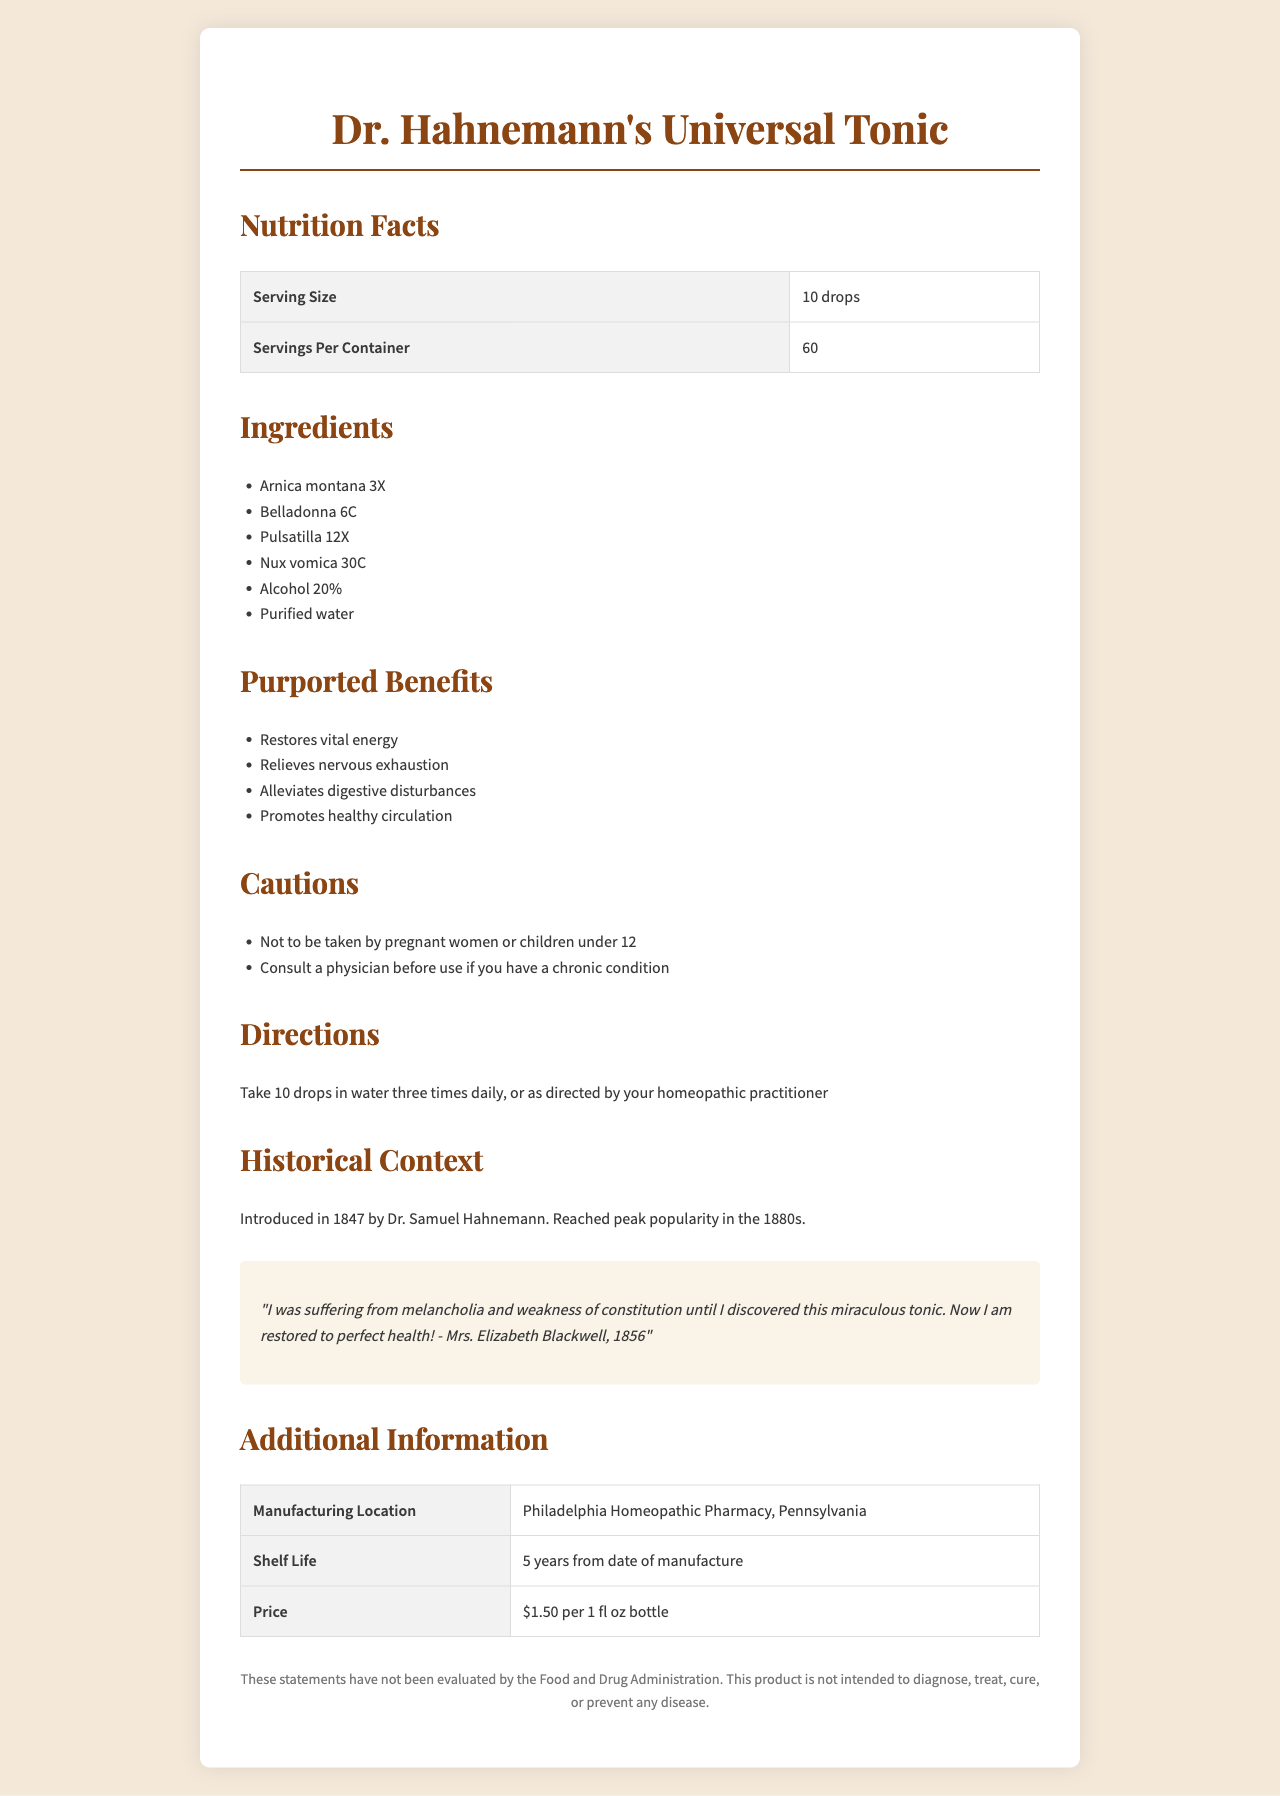what is the serving size? The serving size is listed at the beginning of the nutritional facts section.
Answer: 10 drops how many servings are there per container? The number of servings per container is stated under the serving size information.
Answer: 60 what are the primary ingredients of Dr. Hahnemann's Universal Tonic? The ingredients are clearly listed under the ingredients section.
Answer: Arnica montana 3X, Belladonna 6C, Pulsatilla 12X, Nux vomica 30C, Alcohol 20%, Purified water what year was Dr. Hahnemann's Universal Tonic introduced? The historical context section mentions that the tonic was introduced in 1847.
Answer: 1847 who can take Dr. Hahnemann's Universal Tonic? The cautions section advises that pregnant women and children under 12 should not take it.
Answer: Adults and children over 12 years which of the following is not an ingredient in Dr. Hahnemann's Universal Tonic? A. Arnica montana 3X B. Belladonna 6C C. Echinacea D. Nux vomica 30C The ingredients list does not include Echinacea, while the other options are present.
Answer: C which purported benefit is claimed by Dr. Hahnemann's Universal Tonic? A. Restores vital energy B. Cures infectious diseases C. Enhances memory D. Increases physical strength The benefits list mentions that the tonic "Restores vital energy" but does not mention the other options.
Answer: A can Dr. Hahnemann's Universal Tonic be taken by pregnant women? The cautions section explicitly advises against use by pregnant women.
Answer: No summarize the main idea of the document. This summary encapsulates the key details including the purpose, introduction year, benefits, ingredients, and precautions.
Answer: Dr. Hahnemann's Universal Tonic is a 19th-century homeopathic remedy introduced in 1847, claiming to restore vital energy and alleviate various ailments. It contains ingredients like Arnica montana and Belladonna, and has specific usage directions and cautions. what is the price of Dr. Hahnemann's Universal Tonic per bottle? The price is listed in the additional information section.
Answer: $1.50 per 1 fl oz bottle how many drops of the tonic should be taken daily? The directions state to take 10 drops three times daily, totaling 30 drops.
Answer: 30 drops what is the peak popularity period of Dr. Hahnemann's Universal Tonic? The historical context mentions that the tonic reached peak popularity in the 1880s.
Answer: 1880s where was Dr. Hahnemann's Universal Tonic manufactured? The manufacturing location is provided in the additional information section.
Answer: Philadelphia Homeopathic Pharmacy, Pennsylvania how long is the shelf life of the tonic? The shelf life is listed in the additional information section.
Answer: 5 years from date of manufacture are the health claims of the tonic evaluated by the FDA? The disclaimer notes that the statements have not been evaluated by the Food and Drug Administration.
Answer: No what is the percentage of alcohol in Dr. Hahnemann's Universal Tonic? The ingredients list includes Alcohol 20%.
Answer: 20% how effective is Dr. Hahnemann's Universal Tonic for treating chronic illnesses? The document does not provide specific details on the effectiveness for treating chronic illnesses. The disclaimer also notes that the product is not intended to diagnose, treat, cure, or prevent any disease.
Answer: Not enough information 